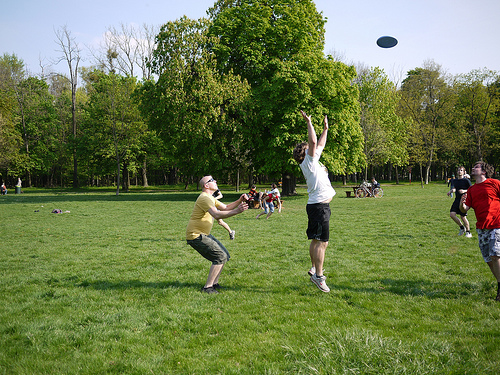Is the ground tall or short? The ground is short, covered in grass, typical for a park-like setting. 